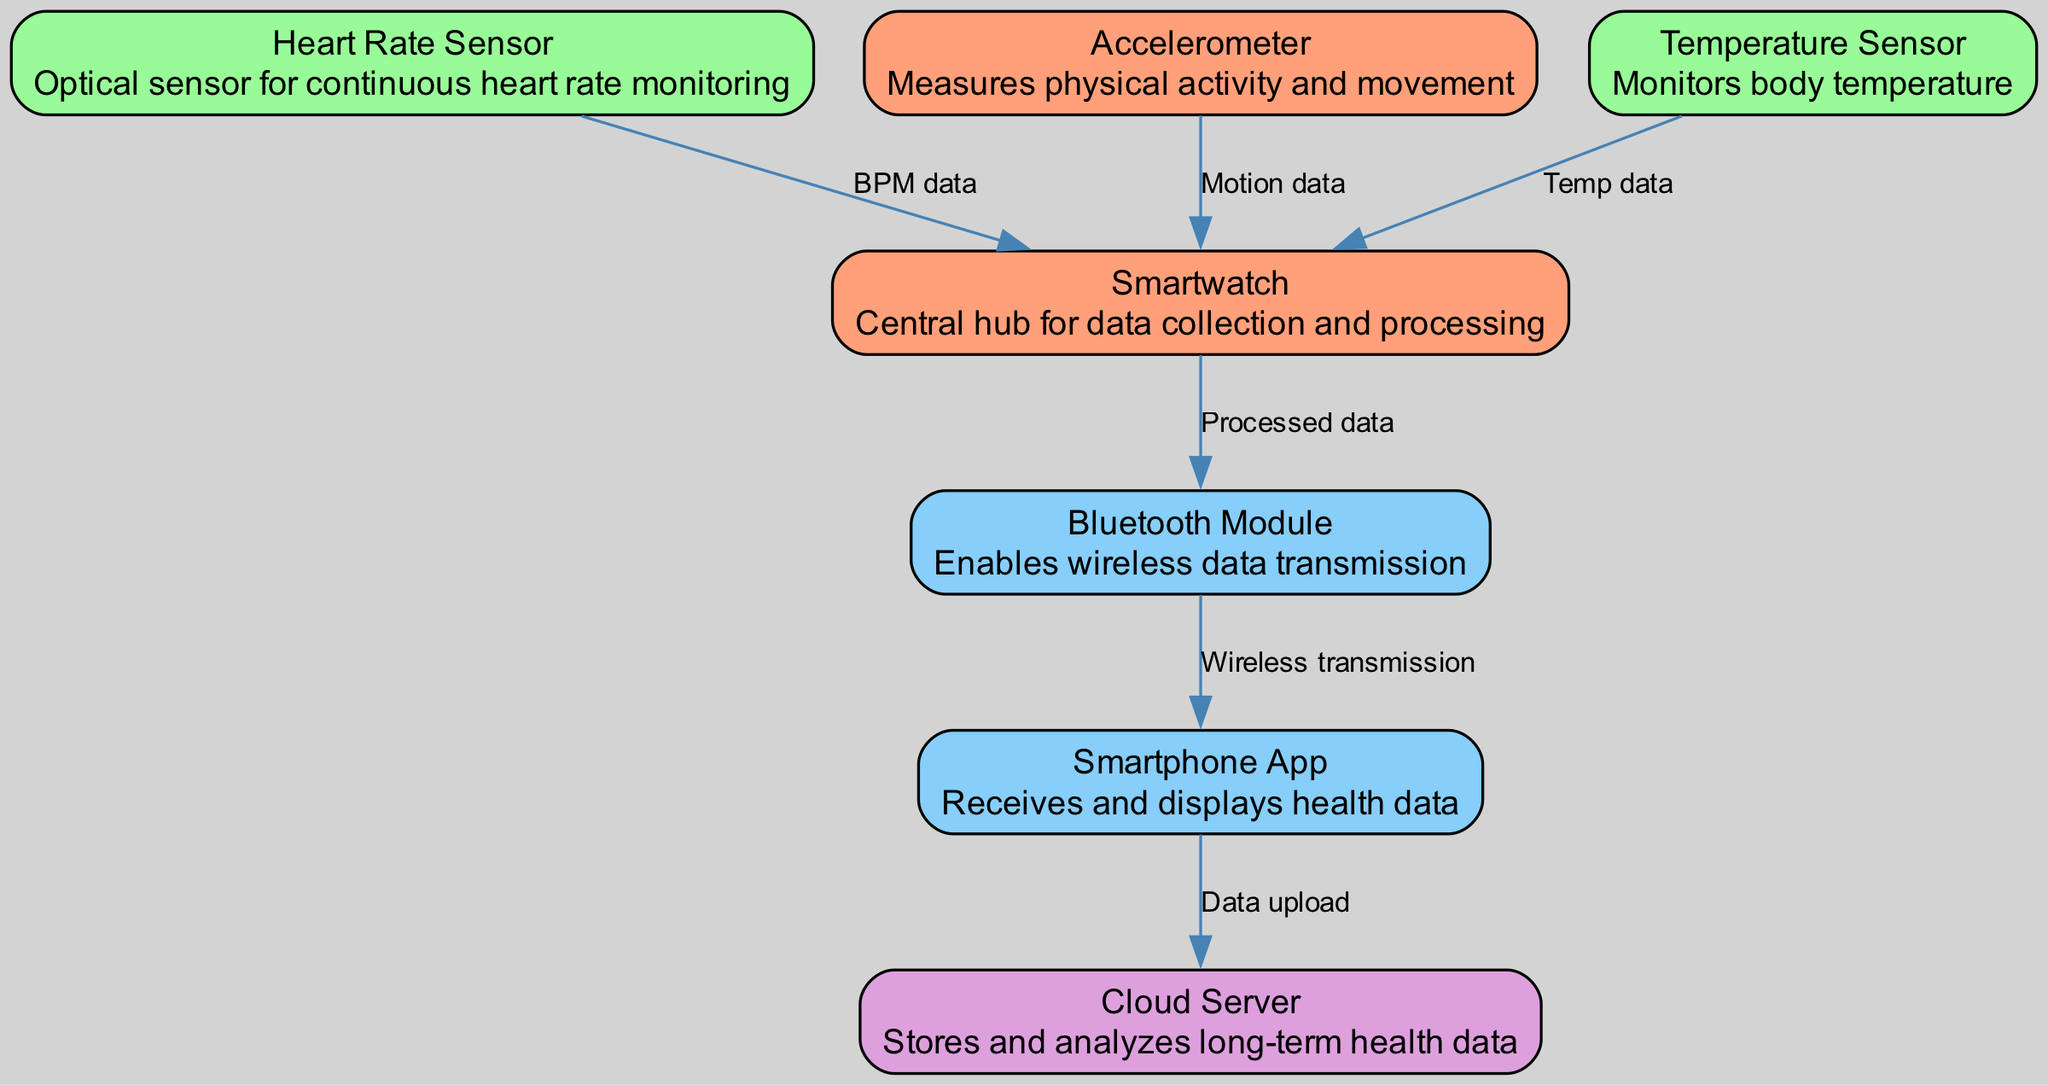What is the central hub for data collection? The diagram indicates that the "Smartwatch" is the central hub for data collection and processing, as it is where data from various sensors is aggregated and processed.
Answer: Smartwatch How many sensors are shown in the diagram? The diagram includes three sensors: Heart Rate Sensor, Accelerometer, and Temperature Sensor. By counting these nodes, we see there are exactly three.
Answer: Three Which sensor is responsible for monitoring body temperature? The "Temperature Sensor" node specifically represents monitoring body temperature in the diagram, as indicated in its label and description.
Answer: Temperature Sensor What type of data does the Accelerometer send to the Smartwatch? The edge from the Accelerometer to the Smartwatch is labeled "Motion data," indicating that this is the type of data being sent.
Answer: Motion data Which module enables wireless data transmission from the Smartwatch? The "Bluetooth Module" is designated in the diagram to enable wireless data transmission, with an outgoing edge from the Smartwatch to it.
Answer: Bluetooth Module How does health data get from the Smartphone to the Cloud? The diagram shows an edge labeled "Data upload" from the Smartphone to the Cloud, indicating that this is the mechanism used for transferring the health data.
Answer: Data upload What is the final destination of the health data flow in the diagram? The health data ultimately flows to the "Cloud Server," which is the last node in the data flow indicated by the diagram.
Answer: Cloud Server What flow of data occurs after the heart rate is measured? After the Heart Rate Sensor measures the heart rate, it sends "BPM data" to the Smartwatch, where it is processed before further transmission.
Answer: BPM data to Smartwatch What type of device is the app on the smartphone? The "Smartphone App" is categorized as an external interface that receives and displays health data, as indicated in its label and description.
Answer: External interface 